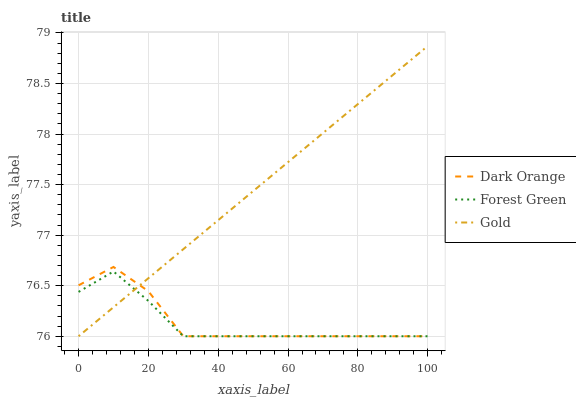Does Forest Green have the minimum area under the curve?
Answer yes or no. Yes. Does Gold have the maximum area under the curve?
Answer yes or no. Yes. Does Gold have the minimum area under the curve?
Answer yes or no. No. Does Forest Green have the maximum area under the curve?
Answer yes or no. No. Is Gold the smoothest?
Answer yes or no. Yes. Is Dark Orange the roughest?
Answer yes or no. Yes. Is Forest Green the smoothest?
Answer yes or no. No. Is Forest Green the roughest?
Answer yes or no. No. Does Dark Orange have the lowest value?
Answer yes or no. Yes. Does Gold have the highest value?
Answer yes or no. Yes. Does Forest Green have the highest value?
Answer yes or no. No. Does Dark Orange intersect Forest Green?
Answer yes or no. Yes. Is Dark Orange less than Forest Green?
Answer yes or no. No. Is Dark Orange greater than Forest Green?
Answer yes or no. No. 